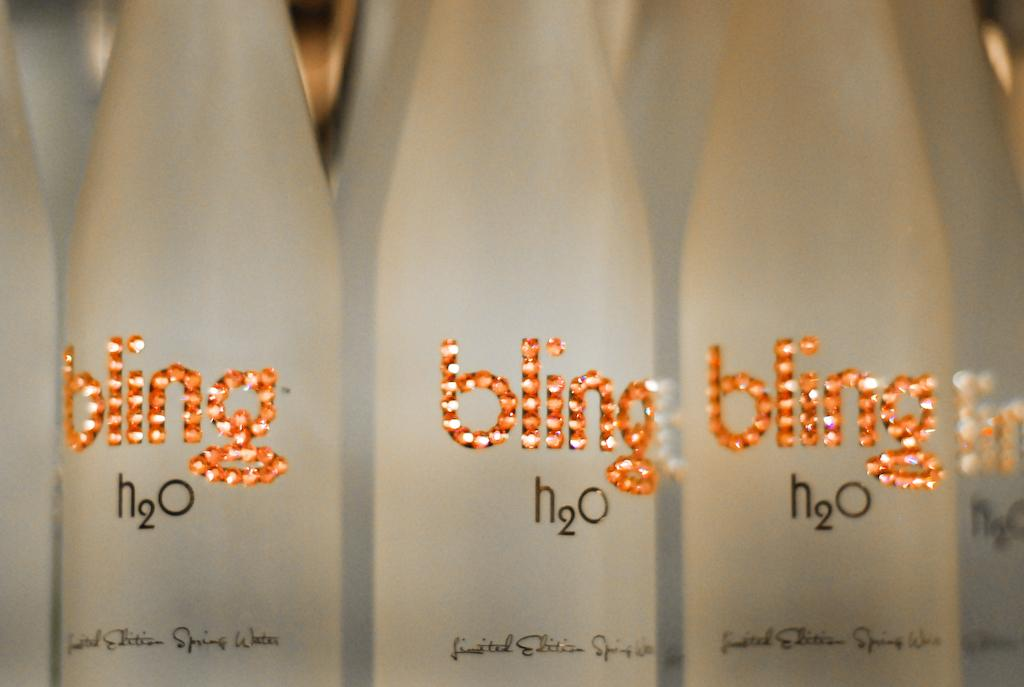<image>
Share a concise interpretation of the image provided. White bottles in a row with logo "bling h2O. 